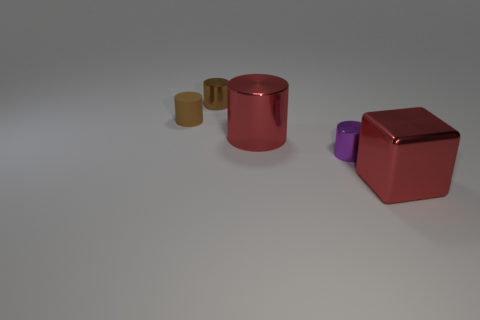Subtract all brown blocks. How many brown cylinders are left? 2 Subtract all red cylinders. How many cylinders are left? 3 Subtract 2 cylinders. How many cylinders are left? 2 Subtract all red cylinders. How many cylinders are left? 3 Add 1 tiny yellow metal blocks. How many objects exist? 6 Subtract all cubes. How many objects are left? 4 Subtract all gray cylinders. Subtract all brown blocks. How many cylinders are left? 4 Subtract 0 gray spheres. How many objects are left? 5 Subtract all cylinders. Subtract all big purple shiny spheres. How many objects are left? 1 Add 2 red shiny things. How many red shiny things are left? 4 